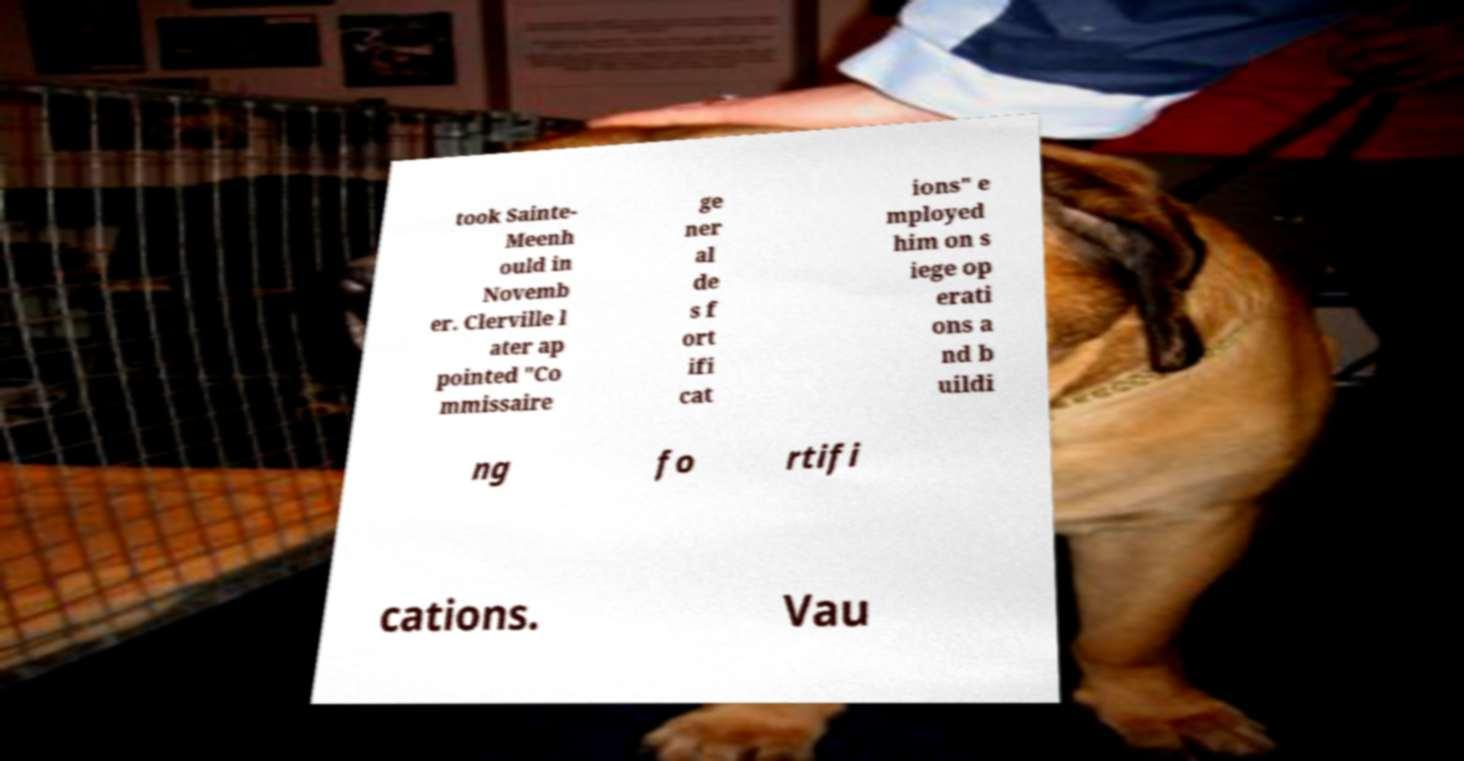For documentation purposes, I need the text within this image transcribed. Could you provide that? took Sainte- Meenh ould in Novemb er. Clerville l ater ap pointed "Co mmissaire ge ner al de s f ort ifi cat ions" e mployed him on s iege op erati ons a nd b uildi ng fo rtifi cations. Vau 